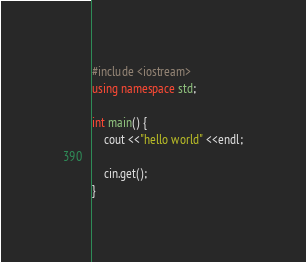<code> <loc_0><loc_0><loc_500><loc_500><_C++_>#include <iostream>
using namespace std;

int main() {
    cout <<"hello world" <<endl;

    cin.get();
}

</code> 